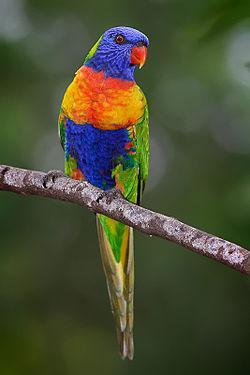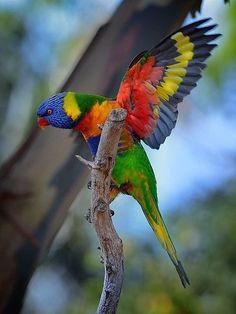The first image is the image on the left, the second image is the image on the right. Examine the images to the left and right. Is the description "All birds have blue heads and are perched on a branch." accurate? Answer yes or no. Yes. The first image is the image on the left, the second image is the image on the right. Assess this claim about the two images: "The left image contains at least three parrots.". Correct or not? Answer yes or no. No. 